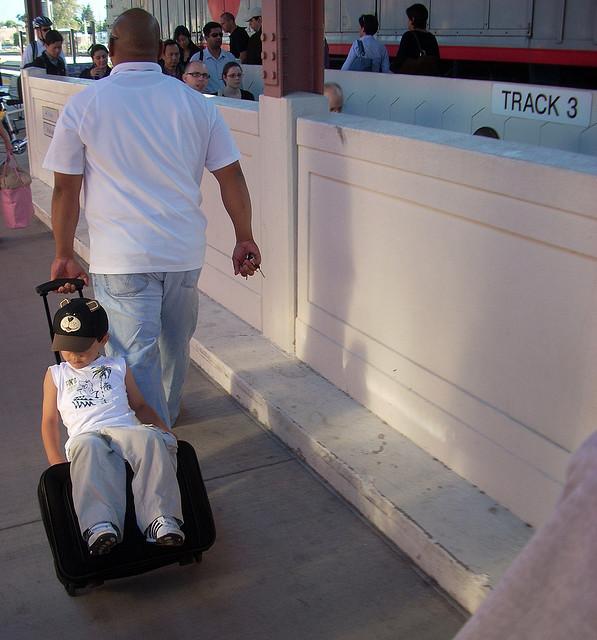Are the two wearing sunglasses?
Short answer required. No. What is the man pulling?
Write a very short answer. Suitcase. Where is the bald man?
Answer briefly. Sidewalk. Is this child old enough to walk?
Write a very short answer. Yes. Is it warm outside?
Keep it brief. Yes. What is the focus of this picture?
Short answer required. Child. Is the kid wearing a hat?
Short answer required. Yes. Is this a way to promote children's career dreams?
Quick response, please. No. 